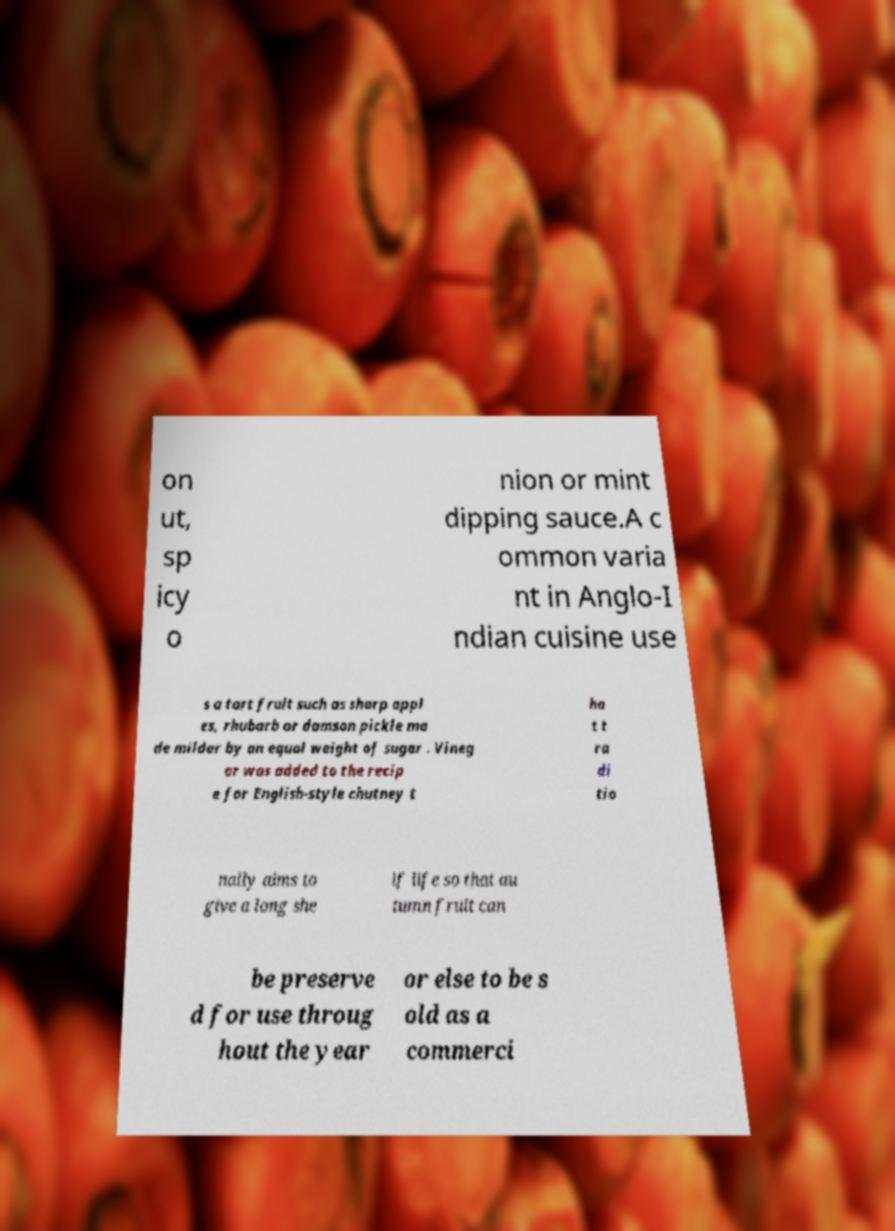Could you assist in decoding the text presented in this image and type it out clearly? on ut, sp icy o nion or mint dipping sauce.A c ommon varia nt in Anglo-I ndian cuisine use s a tart fruit such as sharp appl es, rhubarb or damson pickle ma de milder by an equal weight of sugar . Vineg ar was added to the recip e for English-style chutney t ha t t ra di tio nally aims to give a long she lf life so that au tumn fruit can be preserve d for use throug hout the year or else to be s old as a commerci 